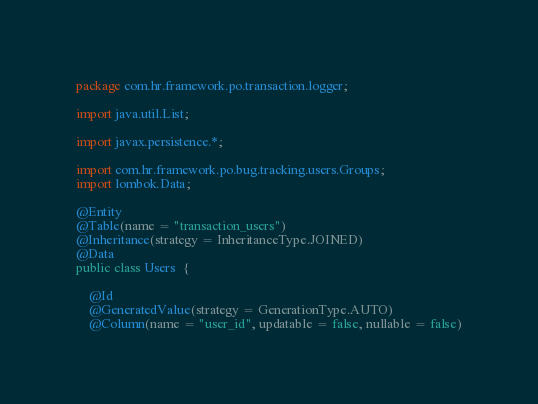<code> <loc_0><loc_0><loc_500><loc_500><_Java_>package com.hr.framework.po.transaction.logger;

import java.util.List;

import javax.persistence.*;

import com.hr.framework.po.bug.tracking.users.Groups;
import lombok.Data;

@Entity
@Table(name = "transaction_users")
@Inheritance(strategy = InheritanceType.JOINED)
@Data
public class Users  {

	@Id
	@GeneratedValue(strategy = GenerationType.AUTO)
	@Column(name = "user_id", updatable = false, nullable = false)</code> 